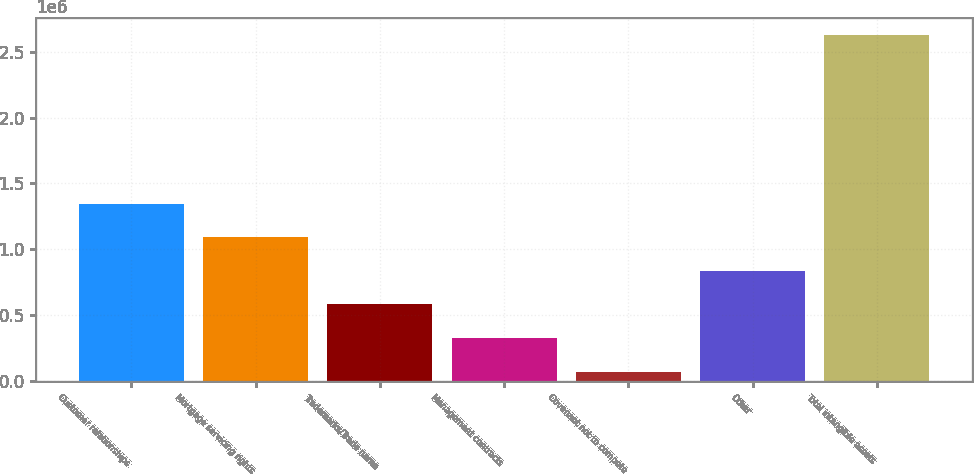<chart> <loc_0><loc_0><loc_500><loc_500><bar_chart><fcel>Customer relationships<fcel>Mortgage servicing rights<fcel>Trademarks/Trade name<fcel>Management contracts<fcel>Covenant not to compete<fcel>Other<fcel>Total intangible assets<nl><fcel>1.34773e+06<fcel>1.09293e+06<fcel>583340<fcel>328545<fcel>73750<fcel>838135<fcel>2.6217e+06<nl></chart> 